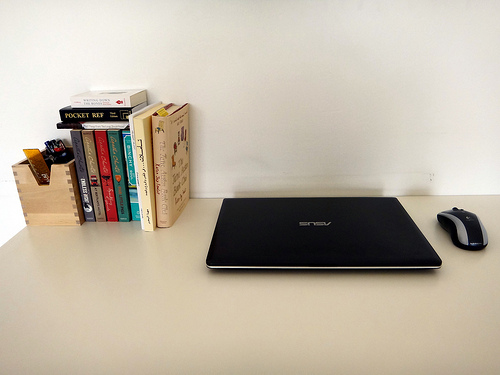<image>
Is the laptop next to the book? Yes. The laptop is positioned adjacent to the book, located nearby in the same general area. Is the book above the computer? No. The book is not positioned above the computer. The vertical arrangement shows a different relationship. 